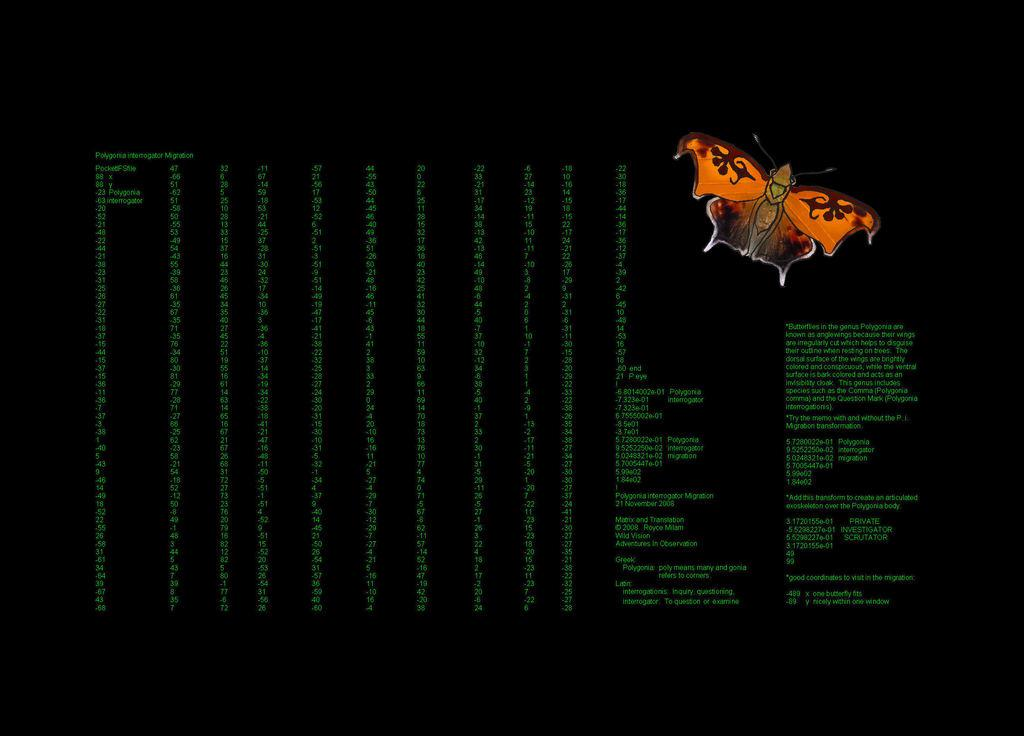What is the overall tone or appearance of the image? The image is dark. What type of creature can be seen in the image? There is a butterfly in the image. Are there any words or letters visible in the image? Yes, there is text visible in the image. How many eggs are being carried by the kite in the image? There is no kite or eggs present in the image. What type of error can be seen in the text of the image? There is no error mentioned in the text of the image, as we do not have information about the content of the text. 